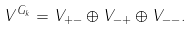Convert formula to latex. <formula><loc_0><loc_0><loc_500><loc_500>V ^ { G _ { k } } = V _ { + - } \oplus V _ { - + } \oplus V _ { - - } .</formula> 